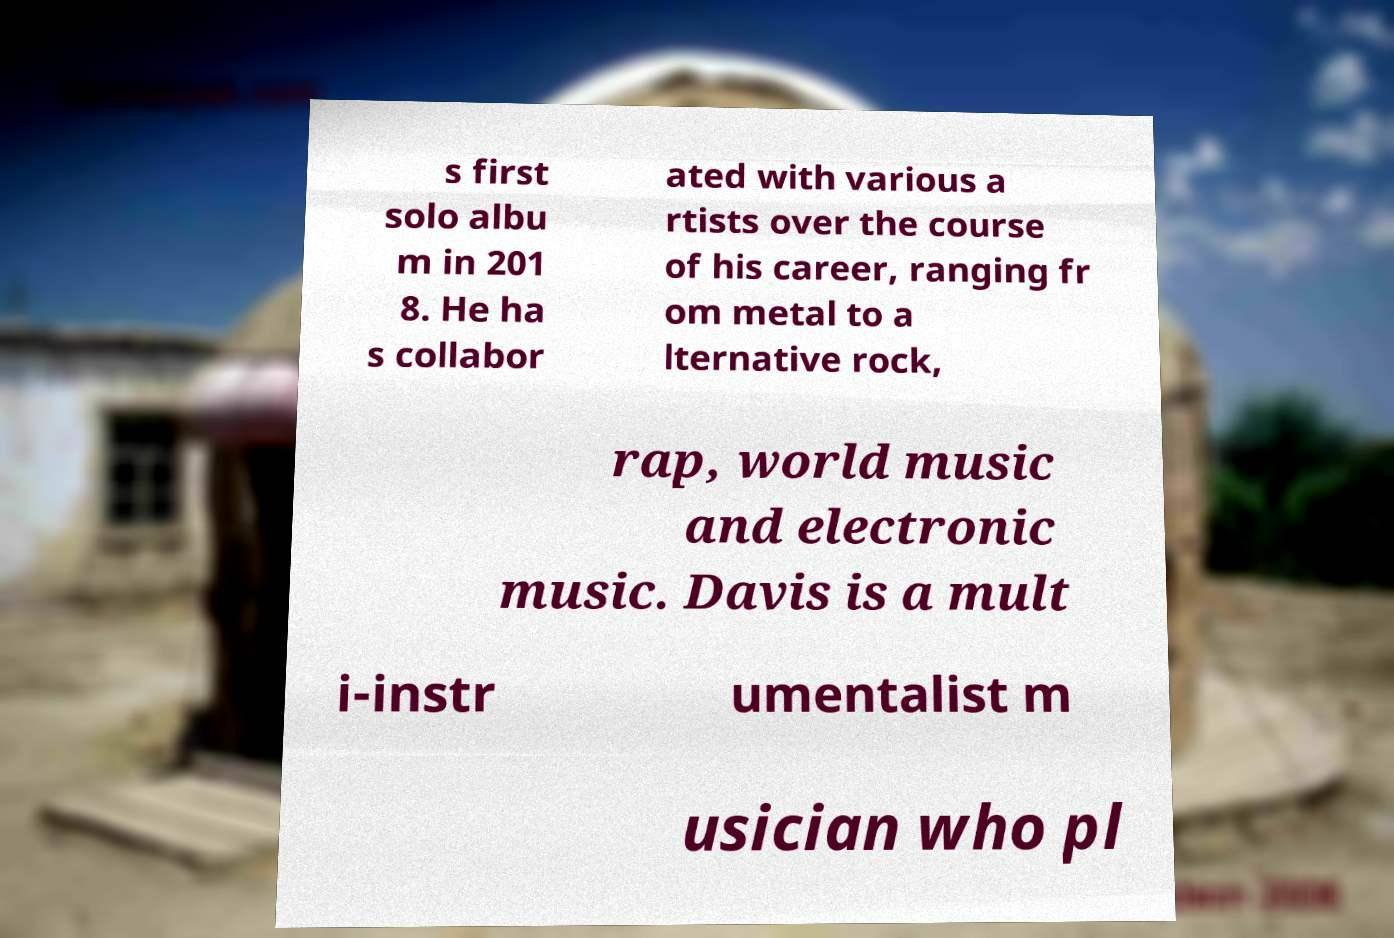I need the written content from this picture converted into text. Can you do that? s first solo albu m in 201 8. He ha s collabor ated with various a rtists over the course of his career, ranging fr om metal to a lternative rock, rap, world music and electronic music. Davis is a mult i-instr umentalist m usician who pl 